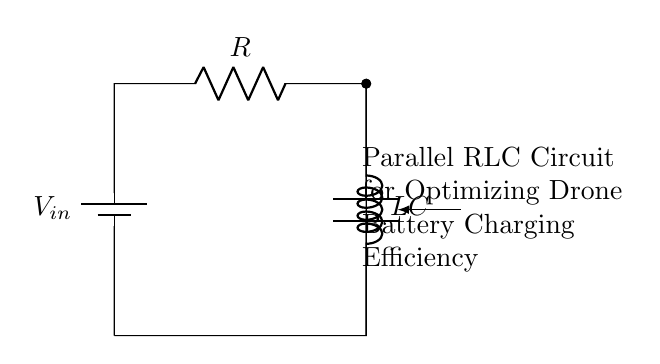What components are present in this circuit? The circuit contains a resistor, inductor, and capacitor, which are shown clearly in the diagram. These components are positioned in parallel, as indicated by the connections.
Answer: Resistor, inductor, capacitor What is the configuration of the components? The components are arranged in parallel, meaning they share the same two nodes for connection, which is evident from their placement in the circuit diagram.
Answer: Parallel What is the main purpose of this circuit? The circuit is designed for optimizing drone battery charging efficiency, as specified in the descriptive text included in the diagram.
Answer: Optimizing battery charging efficiency What happens to current in a parallel RLC circuit? In a parallel RLC circuit, the total current is the sum of the currents through each individual component due to the parallel configuration, which allows multiple paths for current flow.
Answer: Sum of branch currents How does the inductor affect the charging efficiency? The inductor introduces reactance, which can help in filtering and smoothing the current, potentially improving charging efficiency by stabilizing the current supplied to the battery.
Answer: Stabilizes current What role does the capacitor play in this circuit? The capacitor stores and releases energy, which helps manage voltage levels and can improve overall charging efficiency by reducing voltage spikes during the charging process.
Answer: Stores energy How can the values of R, L, and C be selected for optimal performance? The values should be chosen based on the drone battery specifications and charging characteristics, ensuring resonance conditions are met for maximum efficiency in energy transfer.
Answer: Based on battery specifications 